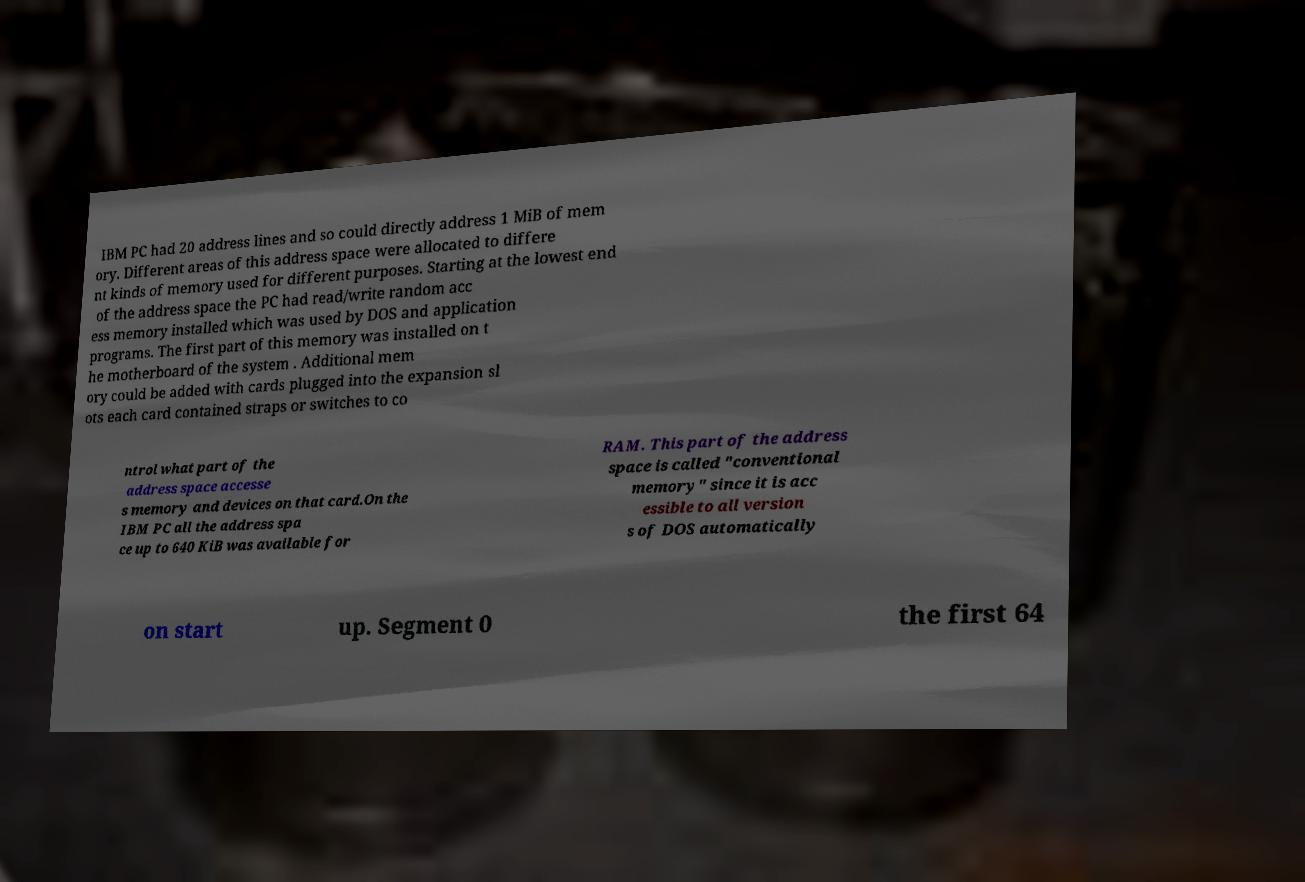For documentation purposes, I need the text within this image transcribed. Could you provide that? IBM PC had 20 address lines and so could directly address 1 MiB of mem ory. Different areas of this address space were allocated to differe nt kinds of memory used for different purposes. Starting at the lowest end of the address space the PC had read/write random acc ess memory installed which was used by DOS and application programs. The first part of this memory was installed on t he motherboard of the system . Additional mem ory could be added with cards plugged into the expansion sl ots each card contained straps or switches to co ntrol what part of the address space accesse s memory and devices on that card.On the IBM PC all the address spa ce up to 640 KiB was available for RAM. This part of the address space is called "conventional memory" since it is acc essible to all version s of DOS automatically on start up. Segment 0 the first 64 